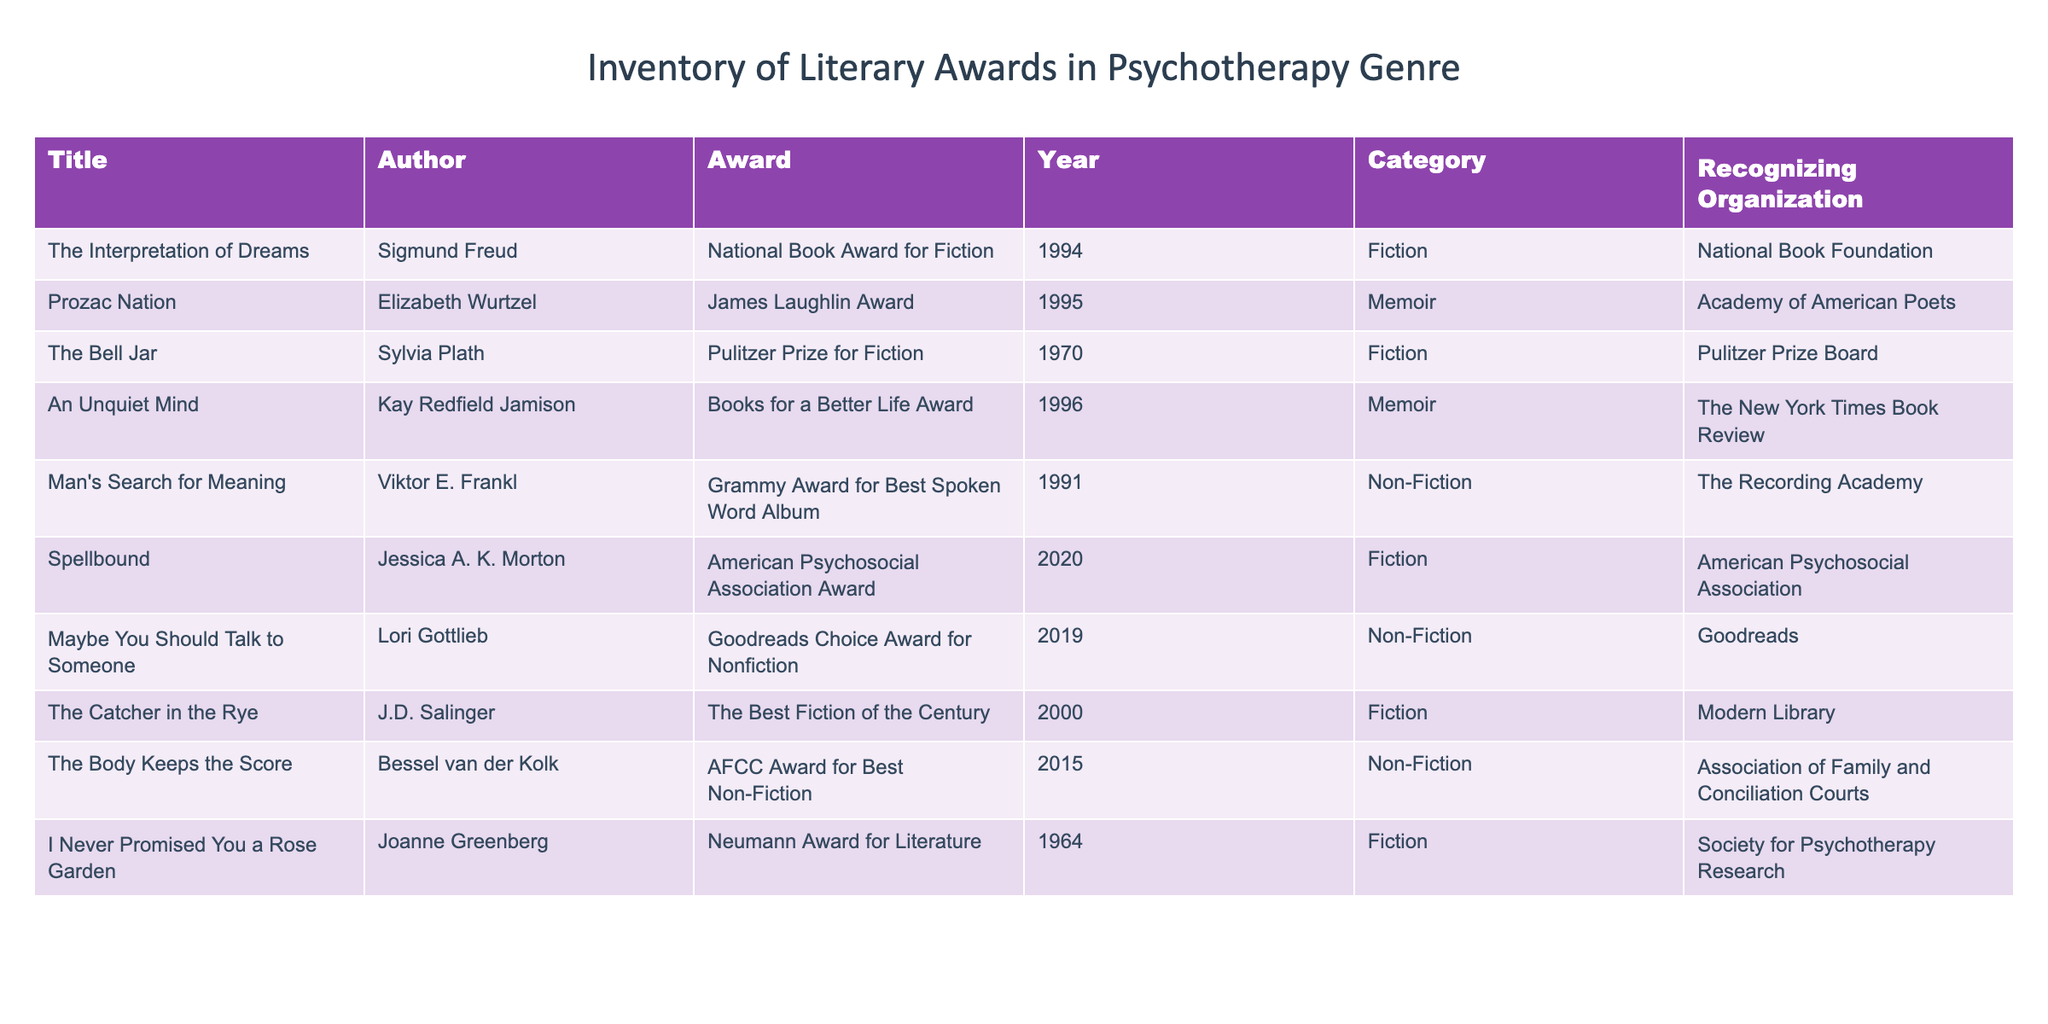What is the title of the novel that won the Pulitzer Prize for Fiction? The table lists various novels along with the awards they received. By scanning the "Award" column for "Pulitzer Prize for Fiction", I find "The Bell Jar" in the "Title" column.
Answer: The Bell Jar Which author received the James Laughlin Award? I look in the "Award" column to find "James Laughlin Award". The corresponding "Author" column shows Elizabeth Wurtzel.
Answer: Elizabeth Wurtzel How many books in the table are categorized as Non-Fiction? To find this, I count the entries in the "Category" column where the value is "Non-Fiction". There are four entries: "Man's Search for Meaning", "Maybe You Should Talk to Someone", "The Body Keeps the Score". Thus, the total is 3.
Answer: 3 Did J.D. Salinger win any award for a memoir? Looking through the "Title" and "Award" columns, I check for any entries where J.D. Salinger is listed with an award related to memoirs. There are no corresponding entries, thus the answer is no.
Answer: No Which novel won the Books for a Better Life Award and in which year? I look for the "Books for a Better Life Award" in the "Award" column. The corresponding "Title" in the same row is "An Unquiet Mind" and the year is 1996.
Answer: An Unquiet Mind, 1996 What is the earliest publication year of a book listed in the table, and which book is it? I look through the "Year" column to find the smallest value. The smallest year is 1964, which corresponds to the title "I Never Promised You a Rose Garden".
Answer: 1964, I Never Promised You a Rose Garden Which organization recognized "The Body Keeps the Score"? By looking at the "Title" column for "The Body Keeps the Score", I check the corresponding "Recognizing Organization" which is "Association of Family and Conciliation Courts".
Answer: Association of Family and Conciliation Courts Is there a book that has won more than one award? I check each title in the "Title" column and see the corresponding awards. None of the books listed have a second award associated with them in this table, so the answer is no.
Answer: No What is the total number of categories represented in the table? I identify the unique categories in the "Category" column: Fiction, Memoir, Non-Fiction. There are 3 distinct categories present.
Answer: 3 